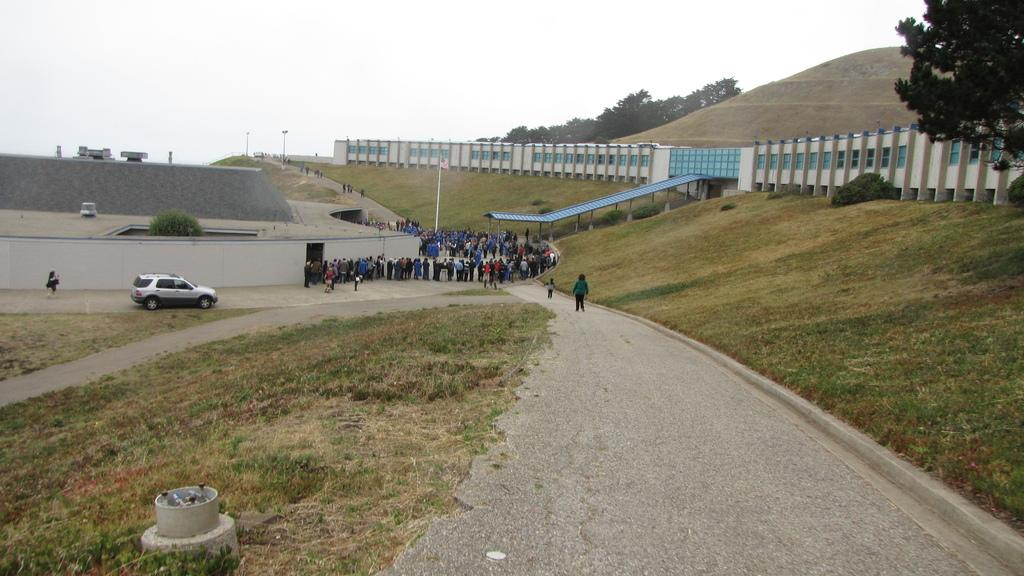How many people are present in the image? There are people in the image, but the exact number cannot be determined from the provided facts. What type of structure can be seen in the image? There is a building and a shed in the image. What other elements are present in the image? There are plants, trees, a car, a concrete surface, poles, and hills in the image. What is visible in the background of the image? The sky is visible in the image. What type of pest can be seen crawling on the canvas in the image? There is no canvas or pest present in the image. 